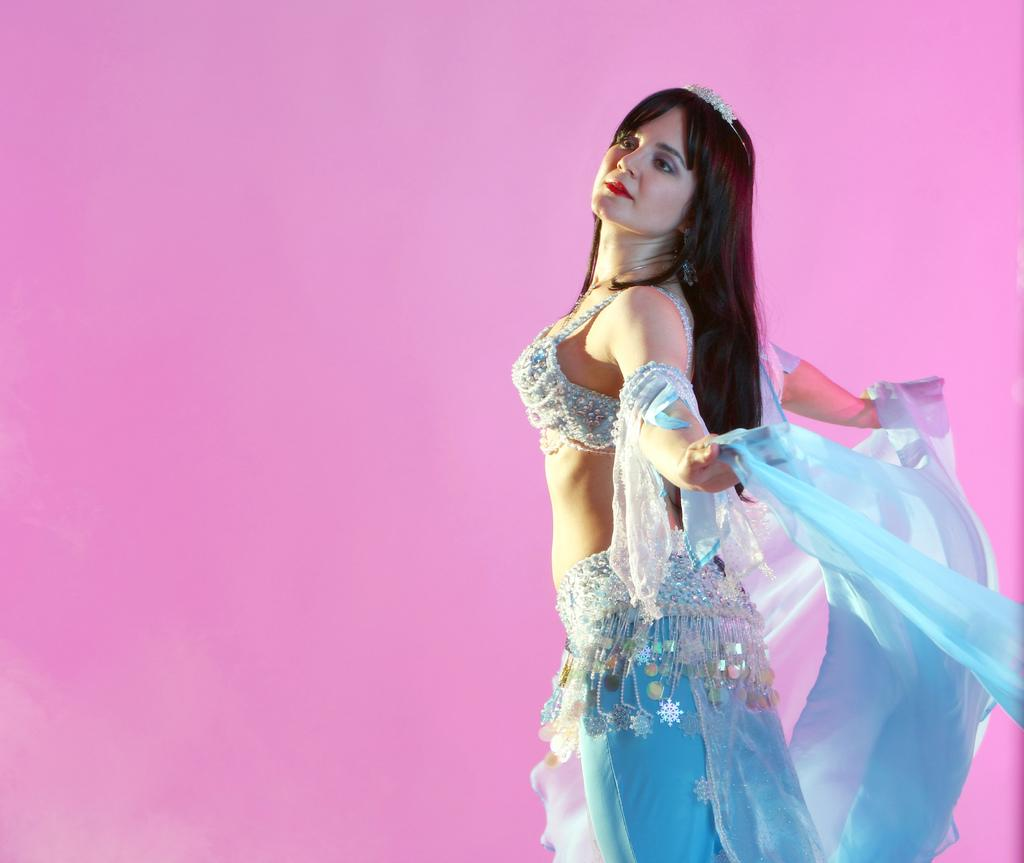Who is the main subject in the image? There is a woman in the image. What is the woman wearing? The woman is wearing a blue dress. How is the woman described? The woman is described as stunning. What is the color of the background in the image? The background in the image is pink. What type of book is the woman holding in the image? There is no book present in the image; the woman is not holding anything. What kind of fuel is being used in the image? There is no reference to fuel or any machinery in the image, so it cannot be determined. 